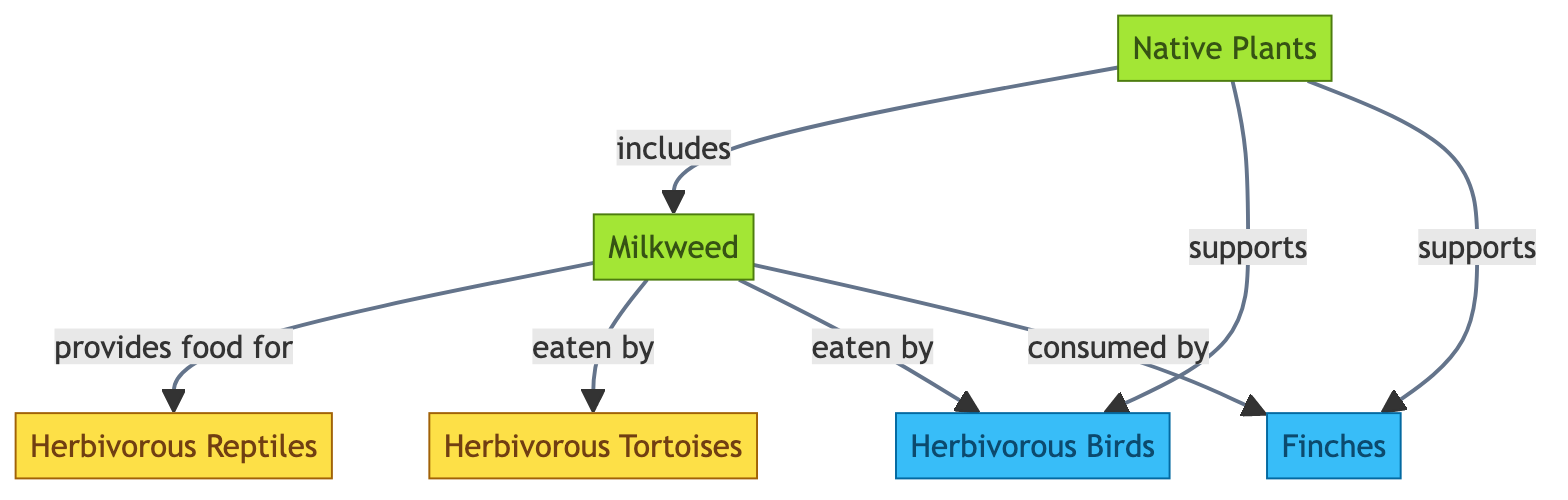What is the primary native plant represented in the diagram? The diagram features "Native Plants" as the primary plant, with "Milkweed" as a specific example included under it.
Answer: Native Plants How many herbivorous reptiles are indicated in the diagram? The diagram shows two herbivorous reptiles: "Herbivorous Reptiles" and "Herbivorous Tortoises." Thus, counting both, we find two distinct identifiers for reptiles.
Answer: 2 Which birds are indicated to consume Milkweed? The diagram states that "Herbivorous Birds" and specifically "Finches" are the birds that consume Milkweed, confirming that both are linked to this plant.
Answer: Herbivorous Birds and Finches What does Milkweed provide food for in the diagram? According to the diagram, Milkweed provides food for "Herbivorous Reptiles," which demonstrates its role in the food chain.
Answer: Herbivorous Reptiles How many edges connect the "Native Plants" node to other nodes? The "Native Plants" node connects to four other nodes, including "Milkweed," "Herbivorous Birds," "Herbivorous Reptiles," and "Finches." Therefore, the total number of edges is four.
Answer: 4 Which animal is directly indicated as being eaten by Herbivorous Tortoises? The diagram shows that "Milkweed" is eaten by "Herbivorous Tortoises," indicating the flow of energy from plants to these reptiles.
Answer: Milkweed What type of animals are supported by native plants according to the diagram? The diagram indicates that "Herbivorous Birds" and "Finches" are supported by native plants, showing the diversity of species that benefit from these plants in the garden.
Answer: Herbivorous Birds and Finches What is the relationship between Milkweed and Finches? The diagram indicates that Finches consume Milkweed, establishing a direct predator-prey relationship.
Answer: consumed by Where does the energy transfer begin in this food chain? The diagram illustrates that energy transfer begins with "Native Plants," which serve as the source in the food chain.
Answer: Native Plants 